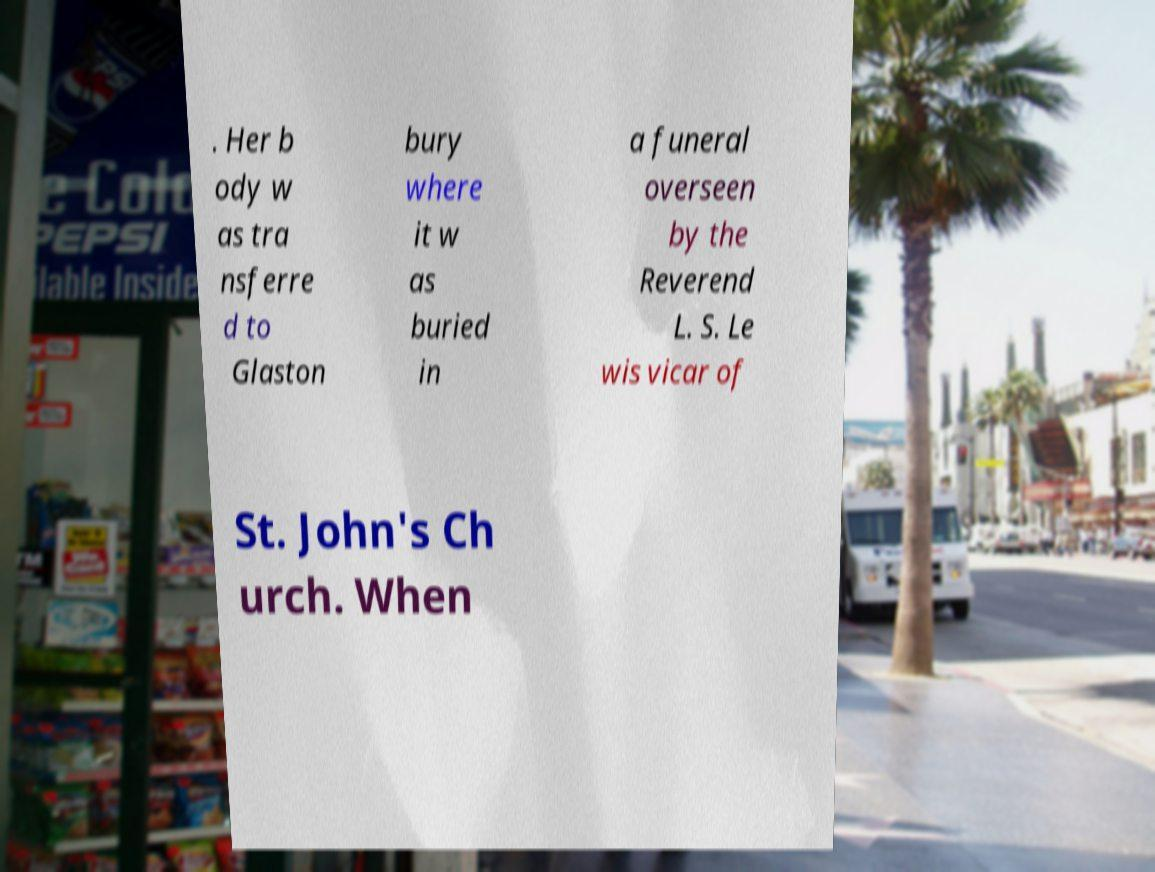Please read and relay the text visible in this image. What does it say? . Her b ody w as tra nsferre d to Glaston bury where it w as buried in a funeral overseen by the Reverend L. S. Le wis vicar of St. John's Ch urch. When 